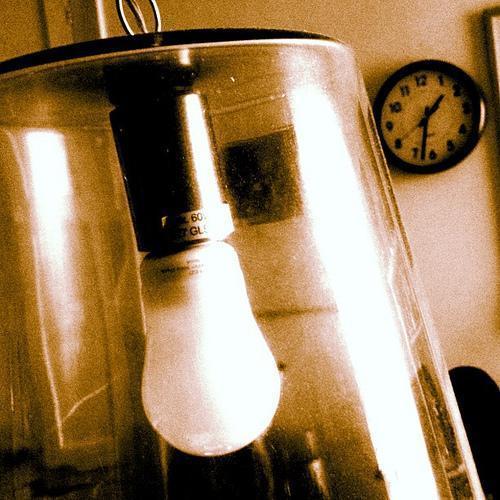How many light bulbs are there?
Give a very brief answer. 1. How many hands does the clock have?
Give a very brief answer. 3. 